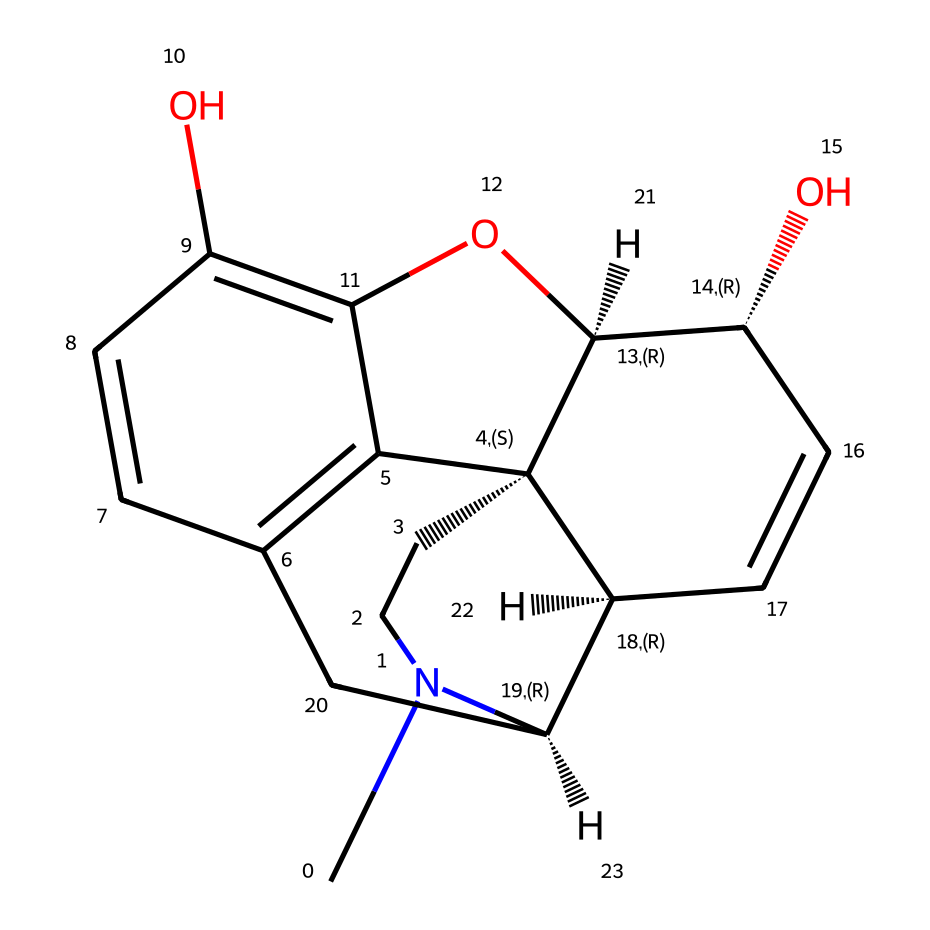What is the molecular formula of morphine? The molecular formula can be derived from the chemical structure by counting the number of each type of atom. In this case, there are 17 carbon atoms, 19 hydrogen atoms, 1 nitrogen atom, and 3 oxygen atoms, giving the molecular formula C17H19N3O3.
Answer: C17H19N3O3 How many rings does morphine have in its structure? By visually inspecting the structure, one can identify the presence of multiple cyclic components. Morphine has 5 rings in its structure, which can be confirmed by tracing the connected cycles of carbon atoms.
Answer: 5 Is morphine a solid, liquid, or gas at room temperature? Morphine, based on its structural data and common knowledge about similar organic compounds, is known to be a solid at room temperature.
Answer: solid What type of compound is morphine classified as? Morphine is classified as an opiate because it is derived from the opium poppy and acts on opioid receptors in the body. The presence of nitrogen and multiple hydroxyl groups also indicates its role as an alkaloid.
Answer: opiate What functional groups are present in morphine? The structure comprises multiple functional groups, including hydroxyl (–OH) groups and a tertiary amine due to the nitrogen atom. These groups are essential for its pharmacological activity.
Answer: hydroxyl, amine Does morphine contain any stereocenters in its molecular structure? By analyzing the chiral centers present in the molecular structure, we can identify that morphine has 5 stereocenters, indicated by the chirality in the carbon atoms.
Answer: 5 How does the structure of morphine relate to its pain relief properties? The molecular structure includes specific functional groups and conformations that allow morphine to bind effectively to opioid receptors, leading to its analgesic (pain-relieving) effects. This structural fit is crucial for its mechanism of action.
Answer: binds to opioid receptors 